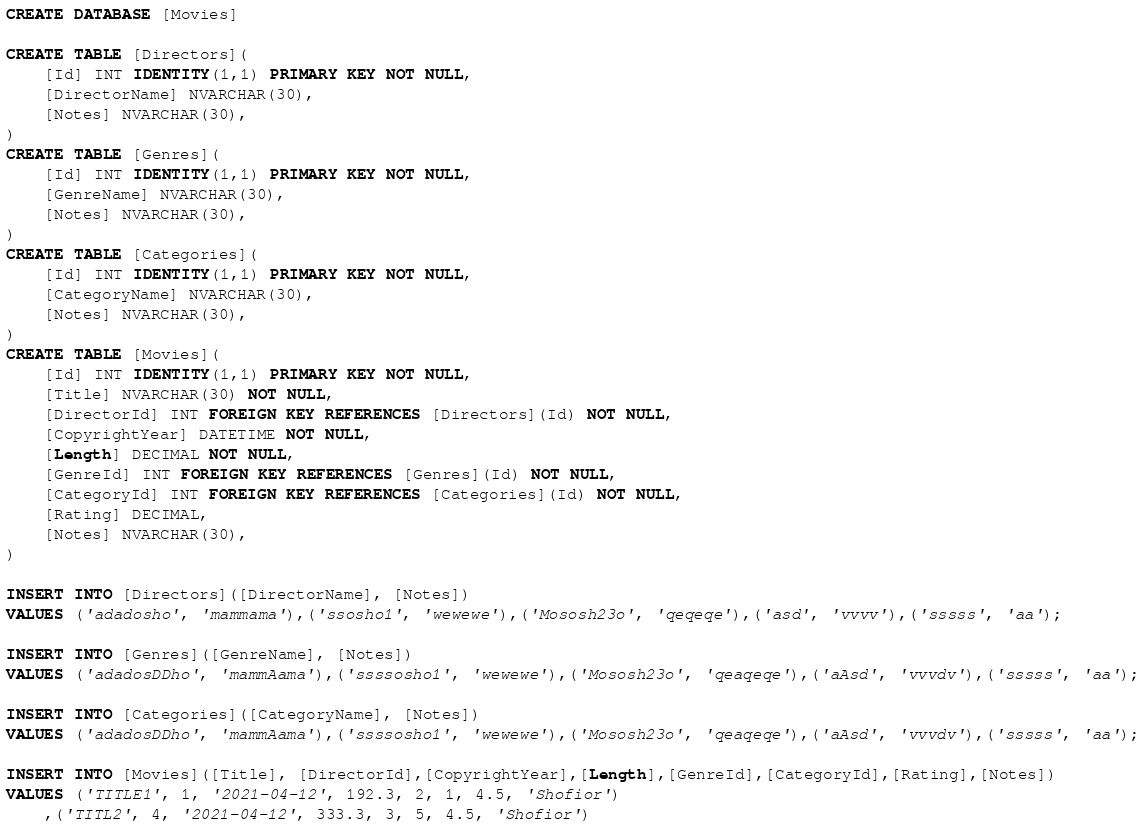<code> <loc_0><loc_0><loc_500><loc_500><_SQL_>CREATE DATABASE [Movies]

CREATE TABLE [Directors](
	[Id] INT IDENTITY(1,1) PRIMARY KEY NOT NULL,
	[DirectorName] NVARCHAR(30),
	[Notes] NVARCHAR(30),
)
CREATE TABLE [Genres](
	[Id] INT IDENTITY(1,1) PRIMARY KEY NOT NULL,
	[GenreName] NVARCHAR(30),
	[Notes] NVARCHAR(30),
)
CREATE TABLE [Categories](
	[Id] INT IDENTITY(1,1) PRIMARY KEY NOT NULL,
	[CategoryName] NVARCHAR(30),
	[Notes] NVARCHAR(30),
)
CREATE TABLE [Movies](
	[Id] INT IDENTITY(1,1) PRIMARY KEY NOT NULL,
	[Title] NVARCHAR(30) NOT NULL,
	[DirectorId] INT FOREIGN KEY REFERENCES [Directors](Id) NOT NULL,
	[CopyrightYear] DATETIME NOT NULL,
	[Length] DECIMAL NOT NULL,
	[GenreId] INT FOREIGN KEY REFERENCES [Genres](Id) NOT NULL,
	[CategoryId] INT FOREIGN KEY REFERENCES [Categories](Id) NOT NULL,
	[Rating] DECIMAL,
	[Notes] NVARCHAR(30),
)

INSERT INTO [Directors]([DirectorName], [Notes])
VALUES ('adadosho', 'mammama'),('ssosho1', 'wewewe'),('Mososh23o', 'qeqeqe'),('asd', 'vvvv'),('sssss', 'aa');

INSERT INTO [Genres]([GenreName], [Notes])
VALUES ('adadosDDho', 'mammAama'),('ssssosho1', 'wewewe'),('Mososh23o', 'qeaqeqe'),('aAsd', 'vvvdv'),('sssss', 'aa');

INSERT INTO [Categories]([CategoryName], [Notes])
VALUES ('adadosDDho', 'mammAama'),('ssssosho1', 'wewewe'),('Mososh23o', 'qeaqeqe'),('aAsd', 'vvvdv'),('sssss', 'aa');

INSERT INTO [Movies]([Title], [DirectorId],[CopyrightYear],[Length],[GenreId],[CategoryId],[Rating],[Notes])
VALUES ('TITLE1', 1, '2021-04-12', 192.3, 2, 1, 4.5, 'Shofior')
	,('TITL2', 4, '2021-04-12', 333.3, 3, 5, 4.5, 'Shofior')</code> 